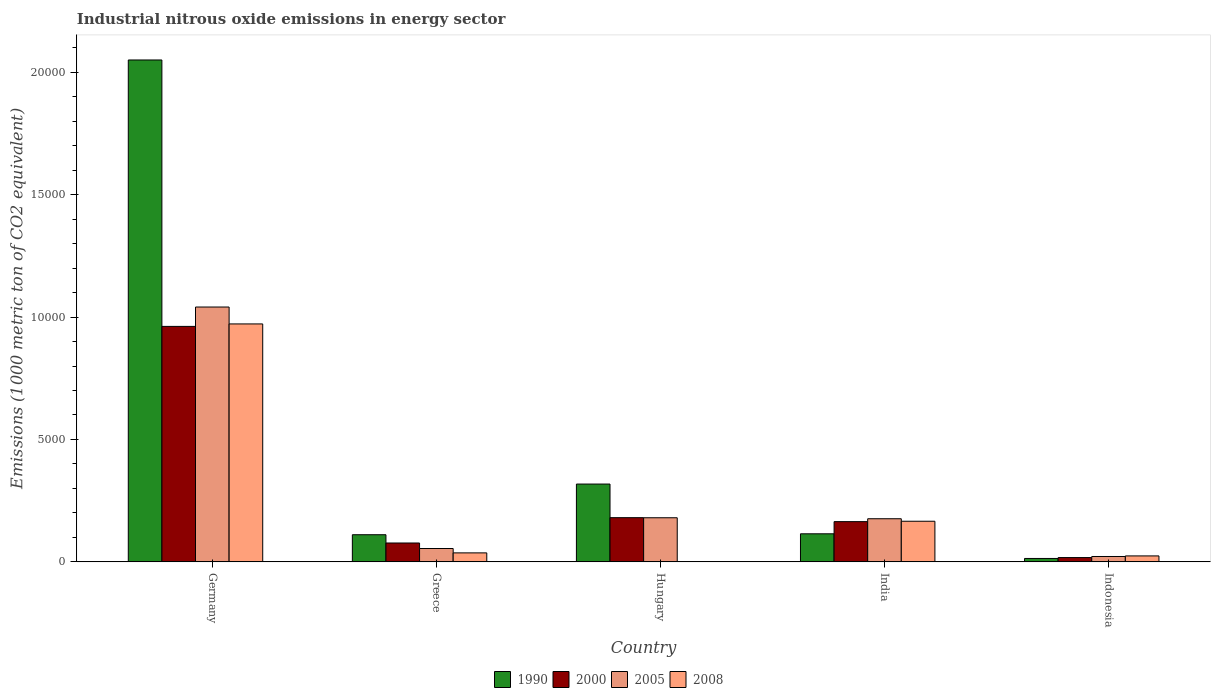Are the number of bars per tick equal to the number of legend labels?
Offer a very short reply. Yes. Are the number of bars on each tick of the X-axis equal?
Your response must be concise. Yes. How many bars are there on the 5th tick from the left?
Make the answer very short. 4. In how many cases, is the number of bars for a given country not equal to the number of legend labels?
Ensure brevity in your answer.  0. What is the amount of industrial nitrous oxide emitted in 2008 in Hungary?
Provide a succinct answer. 6. Across all countries, what is the maximum amount of industrial nitrous oxide emitted in 2008?
Offer a terse response. 9718.4. Across all countries, what is the minimum amount of industrial nitrous oxide emitted in 1990?
Your answer should be very brief. 139.5. In which country was the amount of industrial nitrous oxide emitted in 2005 maximum?
Provide a succinct answer. Germany. In which country was the amount of industrial nitrous oxide emitted in 2000 minimum?
Your response must be concise. Indonesia. What is the total amount of industrial nitrous oxide emitted in 1990 in the graph?
Make the answer very short. 2.61e+04. What is the difference between the amount of industrial nitrous oxide emitted in 2000 in Greece and that in Hungary?
Your answer should be very brief. -1034.4. What is the difference between the amount of industrial nitrous oxide emitted in 2008 in Greece and the amount of industrial nitrous oxide emitted in 2005 in Indonesia?
Your answer should be compact. 147.8. What is the average amount of industrial nitrous oxide emitted in 2005 per country?
Offer a terse response. 2947.64. What is the difference between the amount of industrial nitrous oxide emitted of/in 1990 and amount of industrial nitrous oxide emitted of/in 2000 in India?
Provide a short and direct response. -496.6. What is the ratio of the amount of industrial nitrous oxide emitted in 2008 in Germany to that in Indonesia?
Offer a terse response. 39.94. Is the amount of industrial nitrous oxide emitted in 2000 in Hungary less than that in Indonesia?
Your answer should be compact. No. Is the difference between the amount of industrial nitrous oxide emitted in 1990 in Greece and Indonesia greater than the difference between the amount of industrial nitrous oxide emitted in 2000 in Greece and Indonesia?
Give a very brief answer. Yes. What is the difference between the highest and the second highest amount of industrial nitrous oxide emitted in 2008?
Ensure brevity in your answer.  -8058.6. What is the difference between the highest and the lowest amount of industrial nitrous oxide emitted in 1990?
Your answer should be compact. 2.04e+04. Is it the case that in every country, the sum of the amount of industrial nitrous oxide emitted in 1990 and amount of industrial nitrous oxide emitted in 2000 is greater than the sum of amount of industrial nitrous oxide emitted in 2005 and amount of industrial nitrous oxide emitted in 2008?
Ensure brevity in your answer.  No. What does the 2nd bar from the left in Germany represents?
Your response must be concise. 2000. Is it the case that in every country, the sum of the amount of industrial nitrous oxide emitted in 1990 and amount of industrial nitrous oxide emitted in 2008 is greater than the amount of industrial nitrous oxide emitted in 2005?
Offer a very short reply. Yes. How many countries are there in the graph?
Your answer should be compact. 5. What is the difference between two consecutive major ticks on the Y-axis?
Your response must be concise. 5000. Are the values on the major ticks of Y-axis written in scientific E-notation?
Keep it short and to the point. No. Where does the legend appear in the graph?
Give a very brief answer. Bottom center. What is the title of the graph?
Your answer should be very brief. Industrial nitrous oxide emissions in energy sector. Does "1999" appear as one of the legend labels in the graph?
Your response must be concise. No. What is the label or title of the X-axis?
Offer a very short reply. Country. What is the label or title of the Y-axis?
Provide a short and direct response. Emissions (1000 metric ton of CO2 equivalent). What is the Emissions (1000 metric ton of CO2 equivalent) in 1990 in Germany?
Your answer should be compact. 2.05e+04. What is the Emissions (1000 metric ton of CO2 equivalent) of 2000 in Germany?
Your answer should be very brief. 9617.9. What is the Emissions (1000 metric ton of CO2 equivalent) in 2005 in Germany?
Make the answer very short. 1.04e+04. What is the Emissions (1000 metric ton of CO2 equivalent) of 2008 in Germany?
Provide a short and direct response. 9718.4. What is the Emissions (1000 metric ton of CO2 equivalent) in 1990 in Greece?
Provide a succinct answer. 1109.1. What is the Emissions (1000 metric ton of CO2 equivalent) of 2000 in Greece?
Your answer should be very brief. 771. What is the Emissions (1000 metric ton of CO2 equivalent) of 2005 in Greece?
Your response must be concise. 545.8. What is the Emissions (1000 metric ton of CO2 equivalent) in 2008 in Greece?
Keep it short and to the point. 367.4. What is the Emissions (1000 metric ton of CO2 equivalent) of 1990 in Hungary?
Your answer should be very brief. 3178.6. What is the Emissions (1000 metric ton of CO2 equivalent) of 2000 in Hungary?
Provide a succinct answer. 1805.4. What is the Emissions (1000 metric ton of CO2 equivalent) in 2005 in Hungary?
Your answer should be compact. 1802. What is the Emissions (1000 metric ton of CO2 equivalent) of 1990 in India?
Your response must be concise. 1146.7. What is the Emissions (1000 metric ton of CO2 equivalent) in 2000 in India?
Keep it short and to the point. 1643.3. What is the Emissions (1000 metric ton of CO2 equivalent) in 2005 in India?
Give a very brief answer. 1761.9. What is the Emissions (1000 metric ton of CO2 equivalent) of 2008 in India?
Your response must be concise. 1659.8. What is the Emissions (1000 metric ton of CO2 equivalent) of 1990 in Indonesia?
Offer a terse response. 139.5. What is the Emissions (1000 metric ton of CO2 equivalent) of 2000 in Indonesia?
Provide a succinct answer. 175.8. What is the Emissions (1000 metric ton of CO2 equivalent) of 2005 in Indonesia?
Your answer should be very brief. 219.6. What is the Emissions (1000 metric ton of CO2 equivalent) in 2008 in Indonesia?
Ensure brevity in your answer.  243.3. Across all countries, what is the maximum Emissions (1000 metric ton of CO2 equivalent) of 1990?
Ensure brevity in your answer.  2.05e+04. Across all countries, what is the maximum Emissions (1000 metric ton of CO2 equivalent) of 2000?
Provide a short and direct response. 9617.9. Across all countries, what is the maximum Emissions (1000 metric ton of CO2 equivalent) of 2005?
Make the answer very short. 1.04e+04. Across all countries, what is the maximum Emissions (1000 metric ton of CO2 equivalent) of 2008?
Provide a succinct answer. 9718.4. Across all countries, what is the minimum Emissions (1000 metric ton of CO2 equivalent) in 1990?
Provide a succinct answer. 139.5. Across all countries, what is the minimum Emissions (1000 metric ton of CO2 equivalent) in 2000?
Give a very brief answer. 175.8. Across all countries, what is the minimum Emissions (1000 metric ton of CO2 equivalent) of 2005?
Provide a short and direct response. 219.6. Across all countries, what is the minimum Emissions (1000 metric ton of CO2 equivalent) in 2008?
Keep it short and to the point. 6. What is the total Emissions (1000 metric ton of CO2 equivalent) of 1990 in the graph?
Provide a short and direct response. 2.61e+04. What is the total Emissions (1000 metric ton of CO2 equivalent) in 2000 in the graph?
Provide a short and direct response. 1.40e+04. What is the total Emissions (1000 metric ton of CO2 equivalent) in 2005 in the graph?
Your answer should be compact. 1.47e+04. What is the total Emissions (1000 metric ton of CO2 equivalent) in 2008 in the graph?
Your answer should be very brief. 1.20e+04. What is the difference between the Emissions (1000 metric ton of CO2 equivalent) of 1990 in Germany and that in Greece?
Your response must be concise. 1.94e+04. What is the difference between the Emissions (1000 metric ton of CO2 equivalent) of 2000 in Germany and that in Greece?
Ensure brevity in your answer.  8846.9. What is the difference between the Emissions (1000 metric ton of CO2 equivalent) of 2005 in Germany and that in Greece?
Ensure brevity in your answer.  9863.1. What is the difference between the Emissions (1000 metric ton of CO2 equivalent) in 2008 in Germany and that in Greece?
Your answer should be compact. 9351. What is the difference between the Emissions (1000 metric ton of CO2 equivalent) in 1990 in Germany and that in Hungary?
Offer a terse response. 1.73e+04. What is the difference between the Emissions (1000 metric ton of CO2 equivalent) of 2000 in Germany and that in Hungary?
Your answer should be very brief. 7812.5. What is the difference between the Emissions (1000 metric ton of CO2 equivalent) in 2005 in Germany and that in Hungary?
Make the answer very short. 8606.9. What is the difference between the Emissions (1000 metric ton of CO2 equivalent) of 2008 in Germany and that in Hungary?
Offer a very short reply. 9712.4. What is the difference between the Emissions (1000 metric ton of CO2 equivalent) of 1990 in Germany and that in India?
Provide a succinct answer. 1.94e+04. What is the difference between the Emissions (1000 metric ton of CO2 equivalent) of 2000 in Germany and that in India?
Ensure brevity in your answer.  7974.6. What is the difference between the Emissions (1000 metric ton of CO2 equivalent) of 2005 in Germany and that in India?
Keep it short and to the point. 8647. What is the difference between the Emissions (1000 metric ton of CO2 equivalent) of 2008 in Germany and that in India?
Your answer should be very brief. 8058.6. What is the difference between the Emissions (1000 metric ton of CO2 equivalent) in 1990 in Germany and that in Indonesia?
Give a very brief answer. 2.04e+04. What is the difference between the Emissions (1000 metric ton of CO2 equivalent) in 2000 in Germany and that in Indonesia?
Your answer should be very brief. 9442.1. What is the difference between the Emissions (1000 metric ton of CO2 equivalent) of 2005 in Germany and that in Indonesia?
Make the answer very short. 1.02e+04. What is the difference between the Emissions (1000 metric ton of CO2 equivalent) of 2008 in Germany and that in Indonesia?
Make the answer very short. 9475.1. What is the difference between the Emissions (1000 metric ton of CO2 equivalent) in 1990 in Greece and that in Hungary?
Give a very brief answer. -2069.5. What is the difference between the Emissions (1000 metric ton of CO2 equivalent) in 2000 in Greece and that in Hungary?
Your response must be concise. -1034.4. What is the difference between the Emissions (1000 metric ton of CO2 equivalent) in 2005 in Greece and that in Hungary?
Your response must be concise. -1256.2. What is the difference between the Emissions (1000 metric ton of CO2 equivalent) of 2008 in Greece and that in Hungary?
Your answer should be compact. 361.4. What is the difference between the Emissions (1000 metric ton of CO2 equivalent) of 1990 in Greece and that in India?
Make the answer very short. -37.6. What is the difference between the Emissions (1000 metric ton of CO2 equivalent) of 2000 in Greece and that in India?
Make the answer very short. -872.3. What is the difference between the Emissions (1000 metric ton of CO2 equivalent) of 2005 in Greece and that in India?
Offer a terse response. -1216.1. What is the difference between the Emissions (1000 metric ton of CO2 equivalent) of 2008 in Greece and that in India?
Offer a terse response. -1292.4. What is the difference between the Emissions (1000 metric ton of CO2 equivalent) of 1990 in Greece and that in Indonesia?
Give a very brief answer. 969.6. What is the difference between the Emissions (1000 metric ton of CO2 equivalent) of 2000 in Greece and that in Indonesia?
Keep it short and to the point. 595.2. What is the difference between the Emissions (1000 metric ton of CO2 equivalent) of 2005 in Greece and that in Indonesia?
Offer a very short reply. 326.2. What is the difference between the Emissions (1000 metric ton of CO2 equivalent) of 2008 in Greece and that in Indonesia?
Provide a short and direct response. 124.1. What is the difference between the Emissions (1000 metric ton of CO2 equivalent) of 1990 in Hungary and that in India?
Your answer should be very brief. 2031.9. What is the difference between the Emissions (1000 metric ton of CO2 equivalent) in 2000 in Hungary and that in India?
Your answer should be compact. 162.1. What is the difference between the Emissions (1000 metric ton of CO2 equivalent) of 2005 in Hungary and that in India?
Provide a short and direct response. 40.1. What is the difference between the Emissions (1000 metric ton of CO2 equivalent) in 2008 in Hungary and that in India?
Your answer should be compact. -1653.8. What is the difference between the Emissions (1000 metric ton of CO2 equivalent) of 1990 in Hungary and that in Indonesia?
Provide a succinct answer. 3039.1. What is the difference between the Emissions (1000 metric ton of CO2 equivalent) of 2000 in Hungary and that in Indonesia?
Your answer should be very brief. 1629.6. What is the difference between the Emissions (1000 metric ton of CO2 equivalent) of 2005 in Hungary and that in Indonesia?
Make the answer very short. 1582.4. What is the difference between the Emissions (1000 metric ton of CO2 equivalent) of 2008 in Hungary and that in Indonesia?
Make the answer very short. -237.3. What is the difference between the Emissions (1000 metric ton of CO2 equivalent) in 1990 in India and that in Indonesia?
Ensure brevity in your answer.  1007.2. What is the difference between the Emissions (1000 metric ton of CO2 equivalent) in 2000 in India and that in Indonesia?
Your answer should be very brief. 1467.5. What is the difference between the Emissions (1000 metric ton of CO2 equivalent) in 2005 in India and that in Indonesia?
Keep it short and to the point. 1542.3. What is the difference between the Emissions (1000 metric ton of CO2 equivalent) of 2008 in India and that in Indonesia?
Make the answer very short. 1416.5. What is the difference between the Emissions (1000 metric ton of CO2 equivalent) in 1990 in Germany and the Emissions (1000 metric ton of CO2 equivalent) in 2000 in Greece?
Give a very brief answer. 1.97e+04. What is the difference between the Emissions (1000 metric ton of CO2 equivalent) of 1990 in Germany and the Emissions (1000 metric ton of CO2 equivalent) of 2005 in Greece?
Make the answer very short. 2.00e+04. What is the difference between the Emissions (1000 metric ton of CO2 equivalent) of 1990 in Germany and the Emissions (1000 metric ton of CO2 equivalent) of 2008 in Greece?
Your response must be concise. 2.01e+04. What is the difference between the Emissions (1000 metric ton of CO2 equivalent) in 2000 in Germany and the Emissions (1000 metric ton of CO2 equivalent) in 2005 in Greece?
Keep it short and to the point. 9072.1. What is the difference between the Emissions (1000 metric ton of CO2 equivalent) in 2000 in Germany and the Emissions (1000 metric ton of CO2 equivalent) in 2008 in Greece?
Your answer should be compact. 9250.5. What is the difference between the Emissions (1000 metric ton of CO2 equivalent) in 2005 in Germany and the Emissions (1000 metric ton of CO2 equivalent) in 2008 in Greece?
Ensure brevity in your answer.  1.00e+04. What is the difference between the Emissions (1000 metric ton of CO2 equivalent) of 1990 in Germany and the Emissions (1000 metric ton of CO2 equivalent) of 2000 in Hungary?
Ensure brevity in your answer.  1.87e+04. What is the difference between the Emissions (1000 metric ton of CO2 equivalent) of 1990 in Germany and the Emissions (1000 metric ton of CO2 equivalent) of 2005 in Hungary?
Ensure brevity in your answer.  1.87e+04. What is the difference between the Emissions (1000 metric ton of CO2 equivalent) of 1990 in Germany and the Emissions (1000 metric ton of CO2 equivalent) of 2008 in Hungary?
Offer a very short reply. 2.05e+04. What is the difference between the Emissions (1000 metric ton of CO2 equivalent) of 2000 in Germany and the Emissions (1000 metric ton of CO2 equivalent) of 2005 in Hungary?
Your answer should be compact. 7815.9. What is the difference between the Emissions (1000 metric ton of CO2 equivalent) of 2000 in Germany and the Emissions (1000 metric ton of CO2 equivalent) of 2008 in Hungary?
Make the answer very short. 9611.9. What is the difference between the Emissions (1000 metric ton of CO2 equivalent) of 2005 in Germany and the Emissions (1000 metric ton of CO2 equivalent) of 2008 in Hungary?
Give a very brief answer. 1.04e+04. What is the difference between the Emissions (1000 metric ton of CO2 equivalent) in 1990 in Germany and the Emissions (1000 metric ton of CO2 equivalent) in 2000 in India?
Offer a very short reply. 1.89e+04. What is the difference between the Emissions (1000 metric ton of CO2 equivalent) in 1990 in Germany and the Emissions (1000 metric ton of CO2 equivalent) in 2005 in India?
Make the answer very short. 1.87e+04. What is the difference between the Emissions (1000 metric ton of CO2 equivalent) in 1990 in Germany and the Emissions (1000 metric ton of CO2 equivalent) in 2008 in India?
Your answer should be very brief. 1.88e+04. What is the difference between the Emissions (1000 metric ton of CO2 equivalent) in 2000 in Germany and the Emissions (1000 metric ton of CO2 equivalent) in 2005 in India?
Your answer should be very brief. 7856. What is the difference between the Emissions (1000 metric ton of CO2 equivalent) of 2000 in Germany and the Emissions (1000 metric ton of CO2 equivalent) of 2008 in India?
Ensure brevity in your answer.  7958.1. What is the difference between the Emissions (1000 metric ton of CO2 equivalent) in 2005 in Germany and the Emissions (1000 metric ton of CO2 equivalent) in 2008 in India?
Your answer should be compact. 8749.1. What is the difference between the Emissions (1000 metric ton of CO2 equivalent) of 1990 in Germany and the Emissions (1000 metric ton of CO2 equivalent) of 2000 in Indonesia?
Offer a terse response. 2.03e+04. What is the difference between the Emissions (1000 metric ton of CO2 equivalent) in 1990 in Germany and the Emissions (1000 metric ton of CO2 equivalent) in 2005 in Indonesia?
Offer a very short reply. 2.03e+04. What is the difference between the Emissions (1000 metric ton of CO2 equivalent) of 1990 in Germany and the Emissions (1000 metric ton of CO2 equivalent) of 2008 in Indonesia?
Ensure brevity in your answer.  2.03e+04. What is the difference between the Emissions (1000 metric ton of CO2 equivalent) of 2000 in Germany and the Emissions (1000 metric ton of CO2 equivalent) of 2005 in Indonesia?
Give a very brief answer. 9398.3. What is the difference between the Emissions (1000 metric ton of CO2 equivalent) of 2000 in Germany and the Emissions (1000 metric ton of CO2 equivalent) of 2008 in Indonesia?
Offer a terse response. 9374.6. What is the difference between the Emissions (1000 metric ton of CO2 equivalent) in 2005 in Germany and the Emissions (1000 metric ton of CO2 equivalent) in 2008 in Indonesia?
Offer a very short reply. 1.02e+04. What is the difference between the Emissions (1000 metric ton of CO2 equivalent) of 1990 in Greece and the Emissions (1000 metric ton of CO2 equivalent) of 2000 in Hungary?
Your answer should be compact. -696.3. What is the difference between the Emissions (1000 metric ton of CO2 equivalent) of 1990 in Greece and the Emissions (1000 metric ton of CO2 equivalent) of 2005 in Hungary?
Provide a succinct answer. -692.9. What is the difference between the Emissions (1000 metric ton of CO2 equivalent) of 1990 in Greece and the Emissions (1000 metric ton of CO2 equivalent) of 2008 in Hungary?
Ensure brevity in your answer.  1103.1. What is the difference between the Emissions (1000 metric ton of CO2 equivalent) of 2000 in Greece and the Emissions (1000 metric ton of CO2 equivalent) of 2005 in Hungary?
Offer a terse response. -1031. What is the difference between the Emissions (1000 metric ton of CO2 equivalent) in 2000 in Greece and the Emissions (1000 metric ton of CO2 equivalent) in 2008 in Hungary?
Provide a succinct answer. 765. What is the difference between the Emissions (1000 metric ton of CO2 equivalent) in 2005 in Greece and the Emissions (1000 metric ton of CO2 equivalent) in 2008 in Hungary?
Offer a terse response. 539.8. What is the difference between the Emissions (1000 metric ton of CO2 equivalent) in 1990 in Greece and the Emissions (1000 metric ton of CO2 equivalent) in 2000 in India?
Provide a succinct answer. -534.2. What is the difference between the Emissions (1000 metric ton of CO2 equivalent) in 1990 in Greece and the Emissions (1000 metric ton of CO2 equivalent) in 2005 in India?
Make the answer very short. -652.8. What is the difference between the Emissions (1000 metric ton of CO2 equivalent) of 1990 in Greece and the Emissions (1000 metric ton of CO2 equivalent) of 2008 in India?
Keep it short and to the point. -550.7. What is the difference between the Emissions (1000 metric ton of CO2 equivalent) of 2000 in Greece and the Emissions (1000 metric ton of CO2 equivalent) of 2005 in India?
Keep it short and to the point. -990.9. What is the difference between the Emissions (1000 metric ton of CO2 equivalent) in 2000 in Greece and the Emissions (1000 metric ton of CO2 equivalent) in 2008 in India?
Make the answer very short. -888.8. What is the difference between the Emissions (1000 metric ton of CO2 equivalent) in 2005 in Greece and the Emissions (1000 metric ton of CO2 equivalent) in 2008 in India?
Your response must be concise. -1114. What is the difference between the Emissions (1000 metric ton of CO2 equivalent) of 1990 in Greece and the Emissions (1000 metric ton of CO2 equivalent) of 2000 in Indonesia?
Your response must be concise. 933.3. What is the difference between the Emissions (1000 metric ton of CO2 equivalent) of 1990 in Greece and the Emissions (1000 metric ton of CO2 equivalent) of 2005 in Indonesia?
Provide a succinct answer. 889.5. What is the difference between the Emissions (1000 metric ton of CO2 equivalent) of 1990 in Greece and the Emissions (1000 metric ton of CO2 equivalent) of 2008 in Indonesia?
Offer a terse response. 865.8. What is the difference between the Emissions (1000 metric ton of CO2 equivalent) in 2000 in Greece and the Emissions (1000 metric ton of CO2 equivalent) in 2005 in Indonesia?
Offer a terse response. 551.4. What is the difference between the Emissions (1000 metric ton of CO2 equivalent) of 2000 in Greece and the Emissions (1000 metric ton of CO2 equivalent) of 2008 in Indonesia?
Provide a succinct answer. 527.7. What is the difference between the Emissions (1000 metric ton of CO2 equivalent) in 2005 in Greece and the Emissions (1000 metric ton of CO2 equivalent) in 2008 in Indonesia?
Give a very brief answer. 302.5. What is the difference between the Emissions (1000 metric ton of CO2 equivalent) in 1990 in Hungary and the Emissions (1000 metric ton of CO2 equivalent) in 2000 in India?
Your answer should be very brief. 1535.3. What is the difference between the Emissions (1000 metric ton of CO2 equivalent) of 1990 in Hungary and the Emissions (1000 metric ton of CO2 equivalent) of 2005 in India?
Provide a short and direct response. 1416.7. What is the difference between the Emissions (1000 metric ton of CO2 equivalent) in 1990 in Hungary and the Emissions (1000 metric ton of CO2 equivalent) in 2008 in India?
Your response must be concise. 1518.8. What is the difference between the Emissions (1000 metric ton of CO2 equivalent) of 2000 in Hungary and the Emissions (1000 metric ton of CO2 equivalent) of 2005 in India?
Your answer should be very brief. 43.5. What is the difference between the Emissions (1000 metric ton of CO2 equivalent) of 2000 in Hungary and the Emissions (1000 metric ton of CO2 equivalent) of 2008 in India?
Offer a terse response. 145.6. What is the difference between the Emissions (1000 metric ton of CO2 equivalent) of 2005 in Hungary and the Emissions (1000 metric ton of CO2 equivalent) of 2008 in India?
Provide a succinct answer. 142.2. What is the difference between the Emissions (1000 metric ton of CO2 equivalent) in 1990 in Hungary and the Emissions (1000 metric ton of CO2 equivalent) in 2000 in Indonesia?
Offer a terse response. 3002.8. What is the difference between the Emissions (1000 metric ton of CO2 equivalent) in 1990 in Hungary and the Emissions (1000 metric ton of CO2 equivalent) in 2005 in Indonesia?
Your response must be concise. 2959. What is the difference between the Emissions (1000 metric ton of CO2 equivalent) of 1990 in Hungary and the Emissions (1000 metric ton of CO2 equivalent) of 2008 in Indonesia?
Offer a terse response. 2935.3. What is the difference between the Emissions (1000 metric ton of CO2 equivalent) of 2000 in Hungary and the Emissions (1000 metric ton of CO2 equivalent) of 2005 in Indonesia?
Ensure brevity in your answer.  1585.8. What is the difference between the Emissions (1000 metric ton of CO2 equivalent) of 2000 in Hungary and the Emissions (1000 metric ton of CO2 equivalent) of 2008 in Indonesia?
Provide a succinct answer. 1562.1. What is the difference between the Emissions (1000 metric ton of CO2 equivalent) of 2005 in Hungary and the Emissions (1000 metric ton of CO2 equivalent) of 2008 in Indonesia?
Provide a short and direct response. 1558.7. What is the difference between the Emissions (1000 metric ton of CO2 equivalent) in 1990 in India and the Emissions (1000 metric ton of CO2 equivalent) in 2000 in Indonesia?
Keep it short and to the point. 970.9. What is the difference between the Emissions (1000 metric ton of CO2 equivalent) of 1990 in India and the Emissions (1000 metric ton of CO2 equivalent) of 2005 in Indonesia?
Your answer should be very brief. 927.1. What is the difference between the Emissions (1000 metric ton of CO2 equivalent) in 1990 in India and the Emissions (1000 metric ton of CO2 equivalent) in 2008 in Indonesia?
Your response must be concise. 903.4. What is the difference between the Emissions (1000 metric ton of CO2 equivalent) in 2000 in India and the Emissions (1000 metric ton of CO2 equivalent) in 2005 in Indonesia?
Your answer should be very brief. 1423.7. What is the difference between the Emissions (1000 metric ton of CO2 equivalent) of 2000 in India and the Emissions (1000 metric ton of CO2 equivalent) of 2008 in Indonesia?
Provide a short and direct response. 1400. What is the difference between the Emissions (1000 metric ton of CO2 equivalent) in 2005 in India and the Emissions (1000 metric ton of CO2 equivalent) in 2008 in Indonesia?
Offer a very short reply. 1518.6. What is the average Emissions (1000 metric ton of CO2 equivalent) of 1990 per country?
Your response must be concise. 5214.7. What is the average Emissions (1000 metric ton of CO2 equivalent) in 2000 per country?
Ensure brevity in your answer.  2802.68. What is the average Emissions (1000 metric ton of CO2 equivalent) of 2005 per country?
Make the answer very short. 2947.64. What is the average Emissions (1000 metric ton of CO2 equivalent) in 2008 per country?
Ensure brevity in your answer.  2398.98. What is the difference between the Emissions (1000 metric ton of CO2 equivalent) of 1990 and Emissions (1000 metric ton of CO2 equivalent) of 2000 in Germany?
Your answer should be very brief. 1.09e+04. What is the difference between the Emissions (1000 metric ton of CO2 equivalent) in 1990 and Emissions (1000 metric ton of CO2 equivalent) in 2005 in Germany?
Ensure brevity in your answer.  1.01e+04. What is the difference between the Emissions (1000 metric ton of CO2 equivalent) of 1990 and Emissions (1000 metric ton of CO2 equivalent) of 2008 in Germany?
Your answer should be compact. 1.08e+04. What is the difference between the Emissions (1000 metric ton of CO2 equivalent) in 2000 and Emissions (1000 metric ton of CO2 equivalent) in 2005 in Germany?
Give a very brief answer. -791. What is the difference between the Emissions (1000 metric ton of CO2 equivalent) in 2000 and Emissions (1000 metric ton of CO2 equivalent) in 2008 in Germany?
Offer a terse response. -100.5. What is the difference between the Emissions (1000 metric ton of CO2 equivalent) in 2005 and Emissions (1000 metric ton of CO2 equivalent) in 2008 in Germany?
Offer a terse response. 690.5. What is the difference between the Emissions (1000 metric ton of CO2 equivalent) in 1990 and Emissions (1000 metric ton of CO2 equivalent) in 2000 in Greece?
Provide a succinct answer. 338.1. What is the difference between the Emissions (1000 metric ton of CO2 equivalent) of 1990 and Emissions (1000 metric ton of CO2 equivalent) of 2005 in Greece?
Offer a very short reply. 563.3. What is the difference between the Emissions (1000 metric ton of CO2 equivalent) in 1990 and Emissions (1000 metric ton of CO2 equivalent) in 2008 in Greece?
Your answer should be very brief. 741.7. What is the difference between the Emissions (1000 metric ton of CO2 equivalent) of 2000 and Emissions (1000 metric ton of CO2 equivalent) of 2005 in Greece?
Ensure brevity in your answer.  225.2. What is the difference between the Emissions (1000 metric ton of CO2 equivalent) of 2000 and Emissions (1000 metric ton of CO2 equivalent) of 2008 in Greece?
Offer a terse response. 403.6. What is the difference between the Emissions (1000 metric ton of CO2 equivalent) in 2005 and Emissions (1000 metric ton of CO2 equivalent) in 2008 in Greece?
Provide a short and direct response. 178.4. What is the difference between the Emissions (1000 metric ton of CO2 equivalent) in 1990 and Emissions (1000 metric ton of CO2 equivalent) in 2000 in Hungary?
Provide a short and direct response. 1373.2. What is the difference between the Emissions (1000 metric ton of CO2 equivalent) in 1990 and Emissions (1000 metric ton of CO2 equivalent) in 2005 in Hungary?
Make the answer very short. 1376.6. What is the difference between the Emissions (1000 metric ton of CO2 equivalent) in 1990 and Emissions (1000 metric ton of CO2 equivalent) in 2008 in Hungary?
Ensure brevity in your answer.  3172.6. What is the difference between the Emissions (1000 metric ton of CO2 equivalent) of 2000 and Emissions (1000 metric ton of CO2 equivalent) of 2005 in Hungary?
Your answer should be very brief. 3.4. What is the difference between the Emissions (1000 metric ton of CO2 equivalent) in 2000 and Emissions (1000 metric ton of CO2 equivalent) in 2008 in Hungary?
Your answer should be compact. 1799.4. What is the difference between the Emissions (1000 metric ton of CO2 equivalent) of 2005 and Emissions (1000 metric ton of CO2 equivalent) of 2008 in Hungary?
Give a very brief answer. 1796. What is the difference between the Emissions (1000 metric ton of CO2 equivalent) of 1990 and Emissions (1000 metric ton of CO2 equivalent) of 2000 in India?
Ensure brevity in your answer.  -496.6. What is the difference between the Emissions (1000 metric ton of CO2 equivalent) of 1990 and Emissions (1000 metric ton of CO2 equivalent) of 2005 in India?
Offer a very short reply. -615.2. What is the difference between the Emissions (1000 metric ton of CO2 equivalent) of 1990 and Emissions (1000 metric ton of CO2 equivalent) of 2008 in India?
Your response must be concise. -513.1. What is the difference between the Emissions (1000 metric ton of CO2 equivalent) in 2000 and Emissions (1000 metric ton of CO2 equivalent) in 2005 in India?
Ensure brevity in your answer.  -118.6. What is the difference between the Emissions (1000 metric ton of CO2 equivalent) in 2000 and Emissions (1000 metric ton of CO2 equivalent) in 2008 in India?
Make the answer very short. -16.5. What is the difference between the Emissions (1000 metric ton of CO2 equivalent) of 2005 and Emissions (1000 metric ton of CO2 equivalent) of 2008 in India?
Provide a short and direct response. 102.1. What is the difference between the Emissions (1000 metric ton of CO2 equivalent) in 1990 and Emissions (1000 metric ton of CO2 equivalent) in 2000 in Indonesia?
Your answer should be very brief. -36.3. What is the difference between the Emissions (1000 metric ton of CO2 equivalent) of 1990 and Emissions (1000 metric ton of CO2 equivalent) of 2005 in Indonesia?
Your response must be concise. -80.1. What is the difference between the Emissions (1000 metric ton of CO2 equivalent) in 1990 and Emissions (1000 metric ton of CO2 equivalent) in 2008 in Indonesia?
Keep it short and to the point. -103.8. What is the difference between the Emissions (1000 metric ton of CO2 equivalent) of 2000 and Emissions (1000 metric ton of CO2 equivalent) of 2005 in Indonesia?
Offer a terse response. -43.8. What is the difference between the Emissions (1000 metric ton of CO2 equivalent) of 2000 and Emissions (1000 metric ton of CO2 equivalent) of 2008 in Indonesia?
Ensure brevity in your answer.  -67.5. What is the difference between the Emissions (1000 metric ton of CO2 equivalent) of 2005 and Emissions (1000 metric ton of CO2 equivalent) of 2008 in Indonesia?
Offer a very short reply. -23.7. What is the ratio of the Emissions (1000 metric ton of CO2 equivalent) in 1990 in Germany to that in Greece?
Keep it short and to the point. 18.48. What is the ratio of the Emissions (1000 metric ton of CO2 equivalent) of 2000 in Germany to that in Greece?
Your answer should be compact. 12.47. What is the ratio of the Emissions (1000 metric ton of CO2 equivalent) in 2005 in Germany to that in Greece?
Make the answer very short. 19.07. What is the ratio of the Emissions (1000 metric ton of CO2 equivalent) of 2008 in Germany to that in Greece?
Ensure brevity in your answer.  26.45. What is the ratio of the Emissions (1000 metric ton of CO2 equivalent) of 1990 in Germany to that in Hungary?
Offer a terse response. 6.45. What is the ratio of the Emissions (1000 metric ton of CO2 equivalent) in 2000 in Germany to that in Hungary?
Your answer should be very brief. 5.33. What is the ratio of the Emissions (1000 metric ton of CO2 equivalent) of 2005 in Germany to that in Hungary?
Make the answer very short. 5.78. What is the ratio of the Emissions (1000 metric ton of CO2 equivalent) of 2008 in Germany to that in Hungary?
Your answer should be very brief. 1619.73. What is the ratio of the Emissions (1000 metric ton of CO2 equivalent) of 1990 in Germany to that in India?
Your response must be concise. 17.88. What is the ratio of the Emissions (1000 metric ton of CO2 equivalent) in 2000 in Germany to that in India?
Keep it short and to the point. 5.85. What is the ratio of the Emissions (1000 metric ton of CO2 equivalent) of 2005 in Germany to that in India?
Your answer should be compact. 5.91. What is the ratio of the Emissions (1000 metric ton of CO2 equivalent) in 2008 in Germany to that in India?
Your answer should be very brief. 5.86. What is the ratio of the Emissions (1000 metric ton of CO2 equivalent) in 1990 in Germany to that in Indonesia?
Ensure brevity in your answer.  146.95. What is the ratio of the Emissions (1000 metric ton of CO2 equivalent) in 2000 in Germany to that in Indonesia?
Provide a short and direct response. 54.71. What is the ratio of the Emissions (1000 metric ton of CO2 equivalent) in 2005 in Germany to that in Indonesia?
Ensure brevity in your answer.  47.4. What is the ratio of the Emissions (1000 metric ton of CO2 equivalent) in 2008 in Germany to that in Indonesia?
Offer a terse response. 39.94. What is the ratio of the Emissions (1000 metric ton of CO2 equivalent) in 1990 in Greece to that in Hungary?
Offer a terse response. 0.35. What is the ratio of the Emissions (1000 metric ton of CO2 equivalent) of 2000 in Greece to that in Hungary?
Make the answer very short. 0.43. What is the ratio of the Emissions (1000 metric ton of CO2 equivalent) in 2005 in Greece to that in Hungary?
Offer a very short reply. 0.3. What is the ratio of the Emissions (1000 metric ton of CO2 equivalent) in 2008 in Greece to that in Hungary?
Provide a short and direct response. 61.23. What is the ratio of the Emissions (1000 metric ton of CO2 equivalent) in 1990 in Greece to that in India?
Keep it short and to the point. 0.97. What is the ratio of the Emissions (1000 metric ton of CO2 equivalent) in 2000 in Greece to that in India?
Give a very brief answer. 0.47. What is the ratio of the Emissions (1000 metric ton of CO2 equivalent) in 2005 in Greece to that in India?
Offer a very short reply. 0.31. What is the ratio of the Emissions (1000 metric ton of CO2 equivalent) of 2008 in Greece to that in India?
Your answer should be very brief. 0.22. What is the ratio of the Emissions (1000 metric ton of CO2 equivalent) of 1990 in Greece to that in Indonesia?
Your answer should be very brief. 7.95. What is the ratio of the Emissions (1000 metric ton of CO2 equivalent) in 2000 in Greece to that in Indonesia?
Provide a short and direct response. 4.39. What is the ratio of the Emissions (1000 metric ton of CO2 equivalent) of 2005 in Greece to that in Indonesia?
Provide a succinct answer. 2.49. What is the ratio of the Emissions (1000 metric ton of CO2 equivalent) in 2008 in Greece to that in Indonesia?
Offer a terse response. 1.51. What is the ratio of the Emissions (1000 metric ton of CO2 equivalent) of 1990 in Hungary to that in India?
Provide a succinct answer. 2.77. What is the ratio of the Emissions (1000 metric ton of CO2 equivalent) in 2000 in Hungary to that in India?
Offer a terse response. 1.1. What is the ratio of the Emissions (1000 metric ton of CO2 equivalent) of 2005 in Hungary to that in India?
Offer a terse response. 1.02. What is the ratio of the Emissions (1000 metric ton of CO2 equivalent) in 2008 in Hungary to that in India?
Your answer should be compact. 0. What is the ratio of the Emissions (1000 metric ton of CO2 equivalent) in 1990 in Hungary to that in Indonesia?
Give a very brief answer. 22.79. What is the ratio of the Emissions (1000 metric ton of CO2 equivalent) in 2000 in Hungary to that in Indonesia?
Provide a succinct answer. 10.27. What is the ratio of the Emissions (1000 metric ton of CO2 equivalent) of 2005 in Hungary to that in Indonesia?
Offer a terse response. 8.21. What is the ratio of the Emissions (1000 metric ton of CO2 equivalent) of 2008 in Hungary to that in Indonesia?
Give a very brief answer. 0.02. What is the ratio of the Emissions (1000 metric ton of CO2 equivalent) in 1990 in India to that in Indonesia?
Make the answer very short. 8.22. What is the ratio of the Emissions (1000 metric ton of CO2 equivalent) of 2000 in India to that in Indonesia?
Your answer should be very brief. 9.35. What is the ratio of the Emissions (1000 metric ton of CO2 equivalent) of 2005 in India to that in Indonesia?
Give a very brief answer. 8.02. What is the ratio of the Emissions (1000 metric ton of CO2 equivalent) of 2008 in India to that in Indonesia?
Make the answer very short. 6.82. What is the difference between the highest and the second highest Emissions (1000 metric ton of CO2 equivalent) of 1990?
Make the answer very short. 1.73e+04. What is the difference between the highest and the second highest Emissions (1000 metric ton of CO2 equivalent) of 2000?
Provide a short and direct response. 7812.5. What is the difference between the highest and the second highest Emissions (1000 metric ton of CO2 equivalent) of 2005?
Ensure brevity in your answer.  8606.9. What is the difference between the highest and the second highest Emissions (1000 metric ton of CO2 equivalent) in 2008?
Provide a succinct answer. 8058.6. What is the difference between the highest and the lowest Emissions (1000 metric ton of CO2 equivalent) of 1990?
Keep it short and to the point. 2.04e+04. What is the difference between the highest and the lowest Emissions (1000 metric ton of CO2 equivalent) of 2000?
Your answer should be compact. 9442.1. What is the difference between the highest and the lowest Emissions (1000 metric ton of CO2 equivalent) in 2005?
Offer a very short reply. 1.02e+04. What is the difference between the highest and the lowest Emissions (1000 metric ton of CO2 equivalent) of 2008?
Provide a short and direct response. 9712.4. 